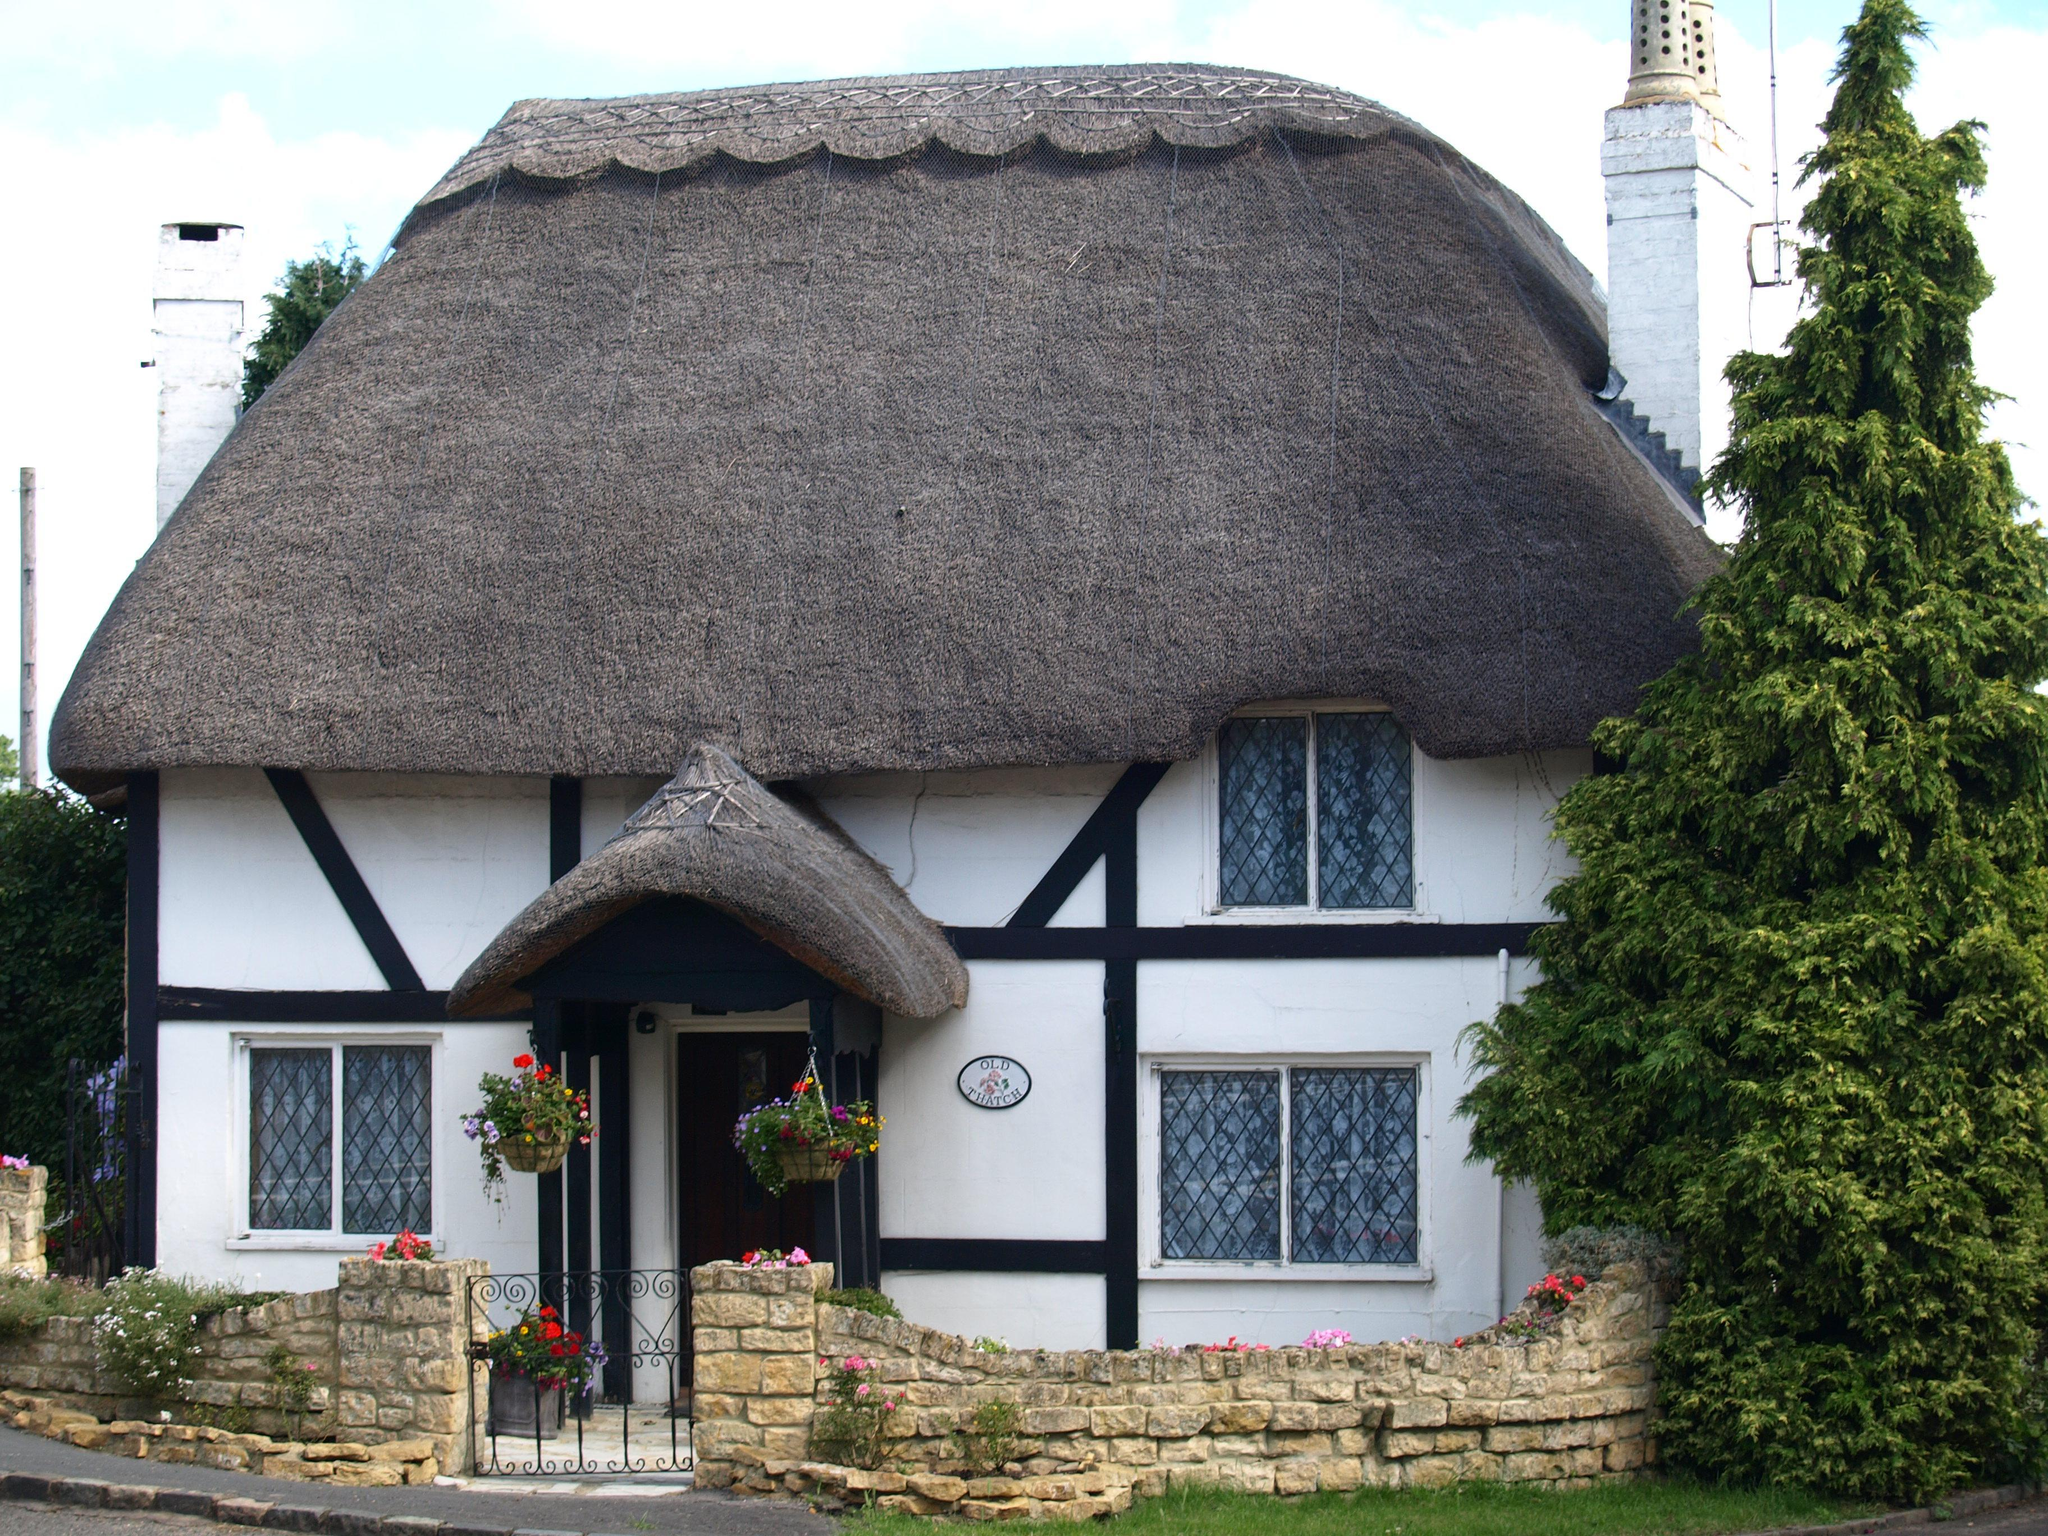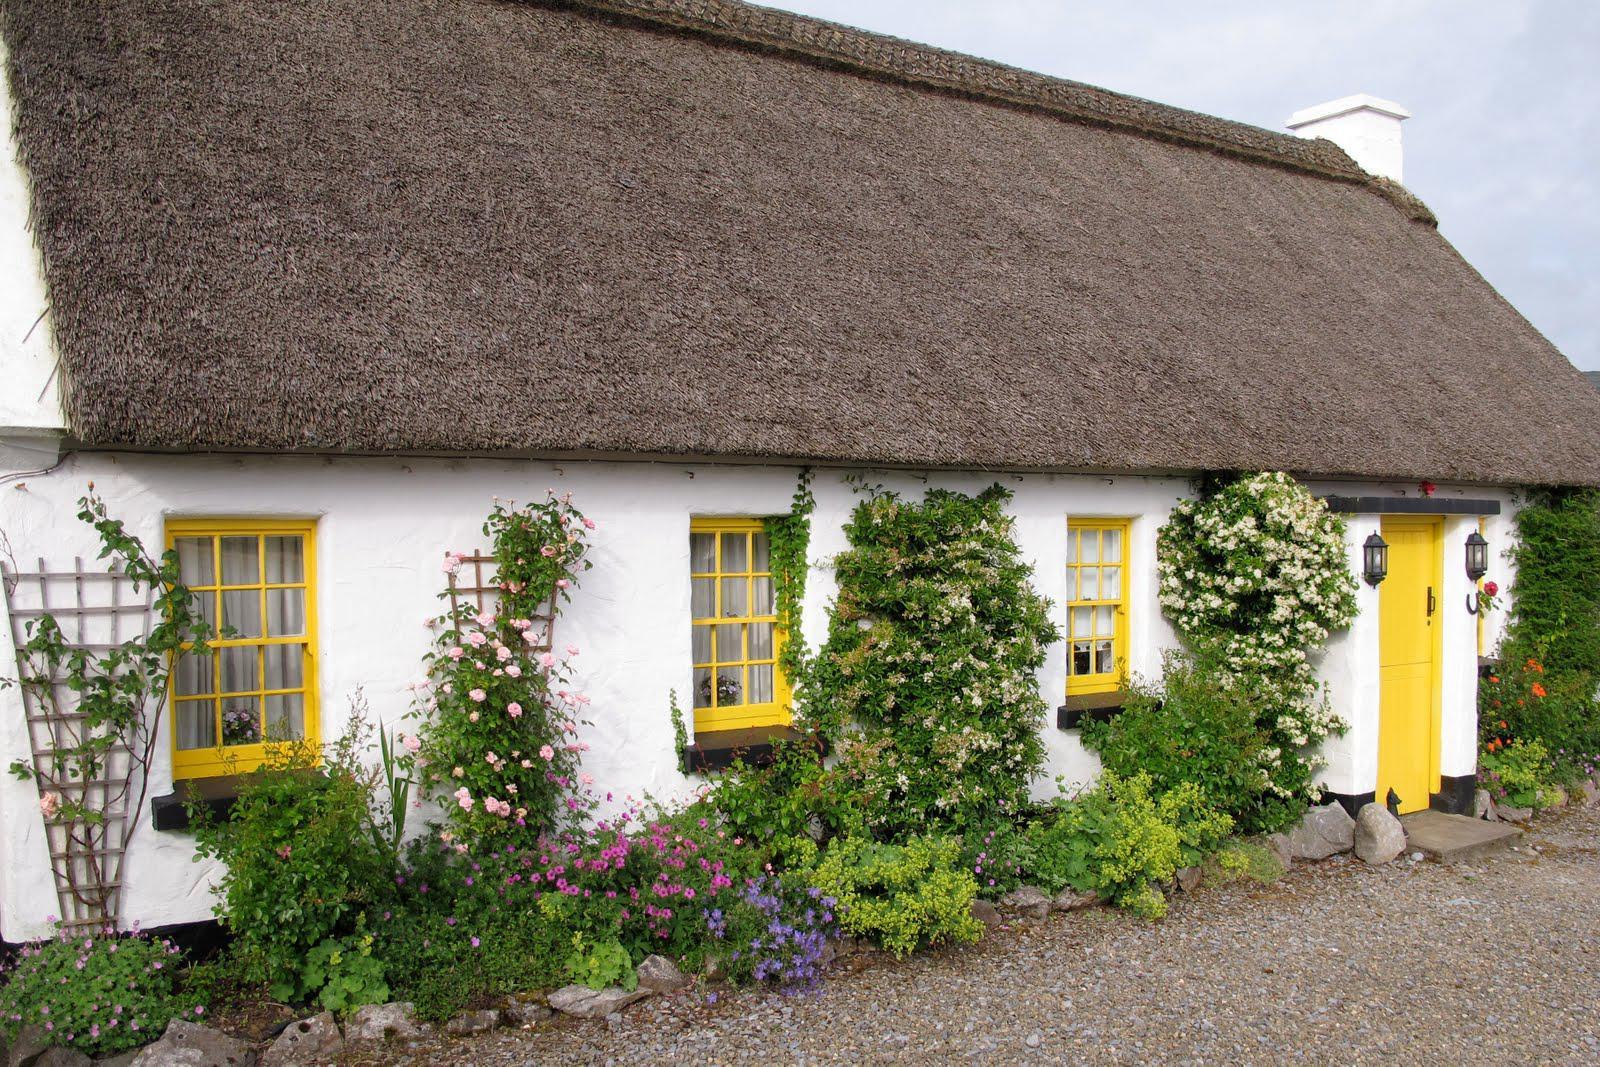The first image is the image on the left, the second image is the image on the right. Evaluate the accuracy of this statement regarding the images: "A building facing leftward has a long thatched roof with two notches on the bottom made to accommodate a door or window.". Is it true? Answer yes or no. No. The first image is the image on the left, the second image is the image on the right. Considering the images on both sides, is "In at least one image there is a white house with black angle strips on it." valid? Answer yes or no. Yes. 